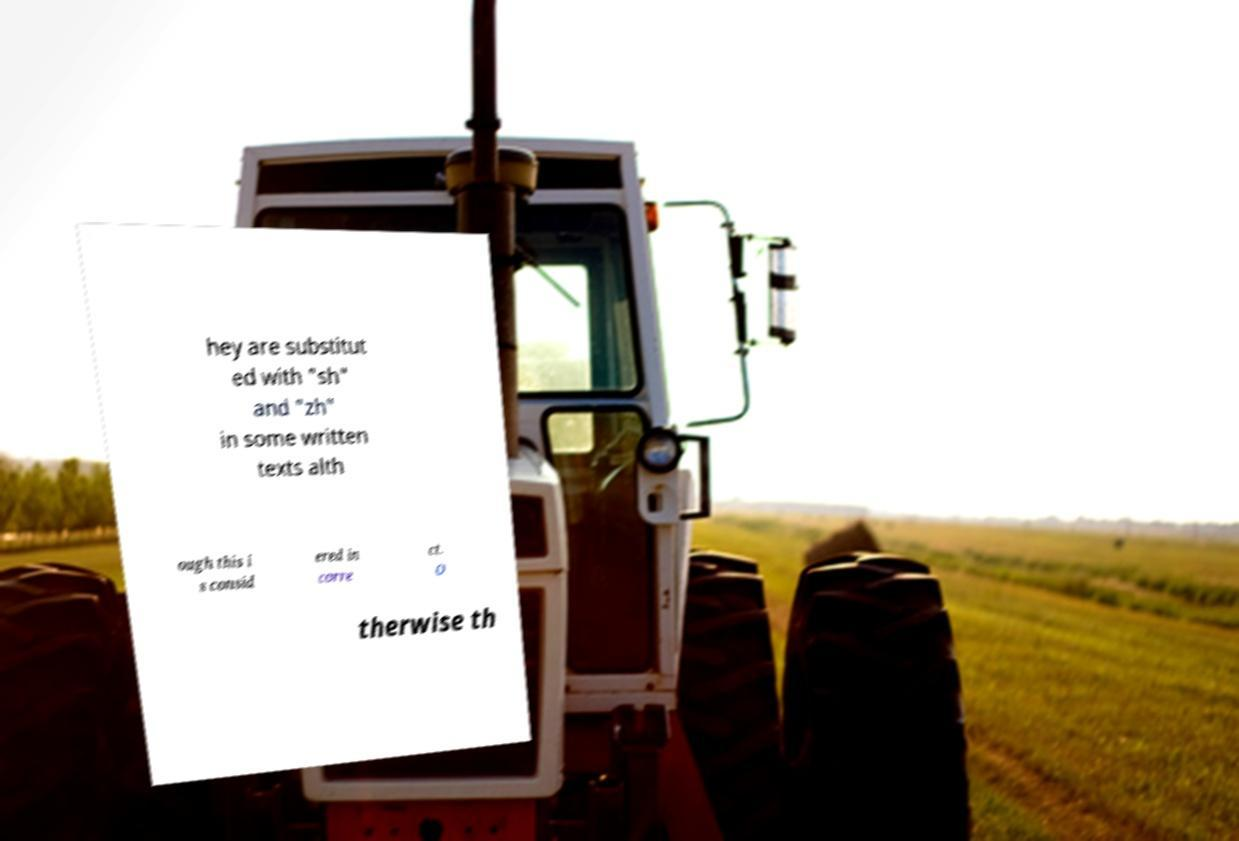There's text embedded in this image that I need extracted. Can you transcribe it verbatim? hey are substitut ed with "sh" and "zh" in some written texts alth ough this i s consid ered in corre ct. O therwise th 